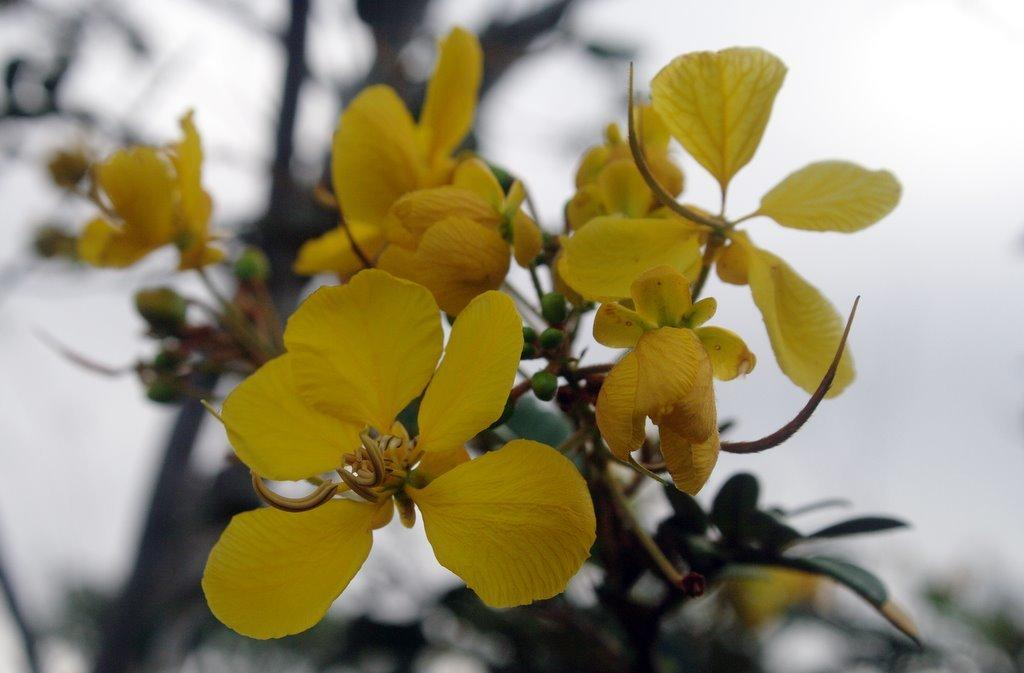What type of flowers can be seen in the image? There are yellow flowers in the image. Are there any flowers that are not fully bloomed in the image? Yes, there are green flower buds in the image. How would you describe the background of the image? The background of the image is blurred. What type of sheet is covering the chin of the lead character in the image? There is no sheet, chin, or lead character present in the image; it features yellow flowers and green flower buds against a blurred background. 